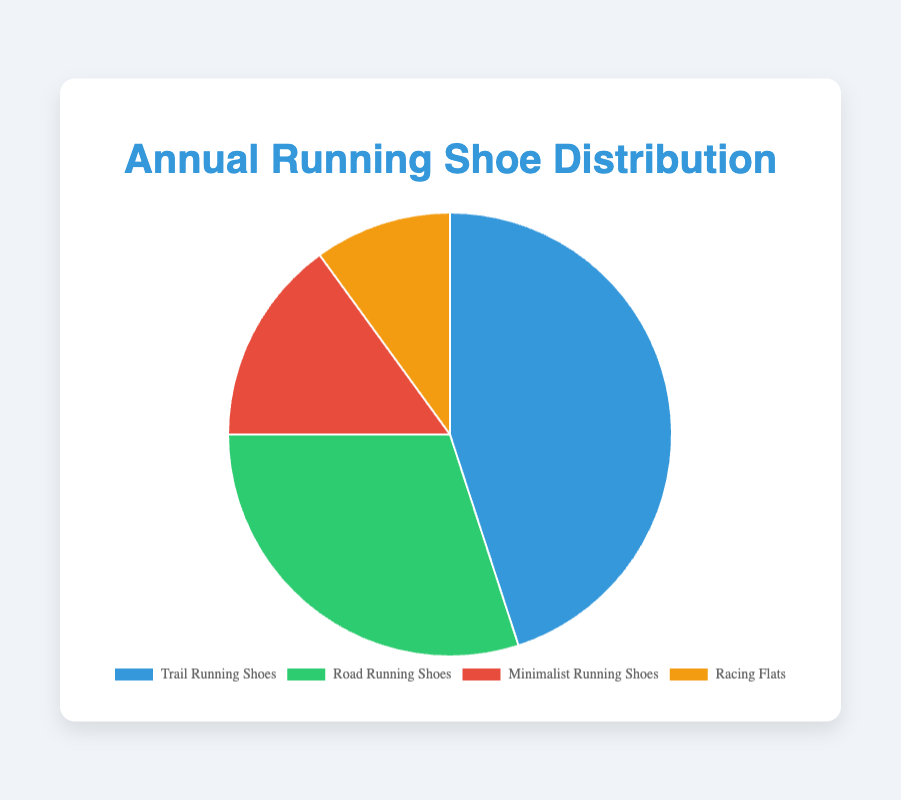What percentage of the total running shoes used annually are Trail Running Shoes? Trail Running Shoes constitute 45 units out of the total 100 units (sum of all shoes). Therefore, the percentage is (45/100) * 100 = 45%.
Answer: 45% Which type of running shoe is used the least annually? According to the pie chart, Racing Flats are used the least, with 10 units.
Answer: Racing Flats What is the combined percentage of Road Running Shoes and Minimalist Running Shoes? The quantities are 30 (Road Running Shoes) and 15 (Minimalist Running Shoes). The combined percentage is ((30+15)/100) * 100 = 45%.
Answer: 45% How many more Trail Running Shoes are used compared to Racing Flats? Trail Running Shoes are 45 units, and Racing Flats are 10 units. The difference is 45 - 10 = 35 units.
Answer: 35 What is the ratio of Trail Running Shoes to Minimalist Running Shoes used? The quantities are 45 (Trail Running Shoes) and 15 (Minimalist Running Shoes). The ratio is 45:15, which simplifies to 3:1.
Answer: 3:1 Which shoe category has the second highest usage annually and how many units are used? The second highest category is Road Running Shoes, with 30 units.
Answer: Road Running Shoes, 30 By what factor is the usage of Trail Running Shoes greater than that of Racing Flats? Trail Running Shoes are 45 units, and Racing Flats are 10 units. The factor is 45 / 10 = 4.5.
Answer: 4.5 What is the percentage difference between the usage of Road Running Shoes and Minimalist Running Shoes? The quantities are 30 (Road Running Shoes) and 15 (Minimalist Running Shoes). The percentage difference is ((30 - 15) / 100) * 100 = 15%.
Answer: 15% If you combined the usage of Racing Flats and Minimalist Running Shoes, how would their total compare to Trail Running Shoes? Racing Flats and Minimalist Running Shoes together sum up to 10 + 15 = 25 units. Trail Running Shoes are 45 units. The difference is 45 - 25 = 20 units.
Answer: 20 units What color represents the category with the highest usage? The pie chart shows colors representing each category: Trail Running Shoes are blue, Road Running Shoes are green, Minimalist Running Shoes are red, and Racing Flats are orange. Trail Running Shoes have the highest usage and are represented by blue.
Answer: Blue 